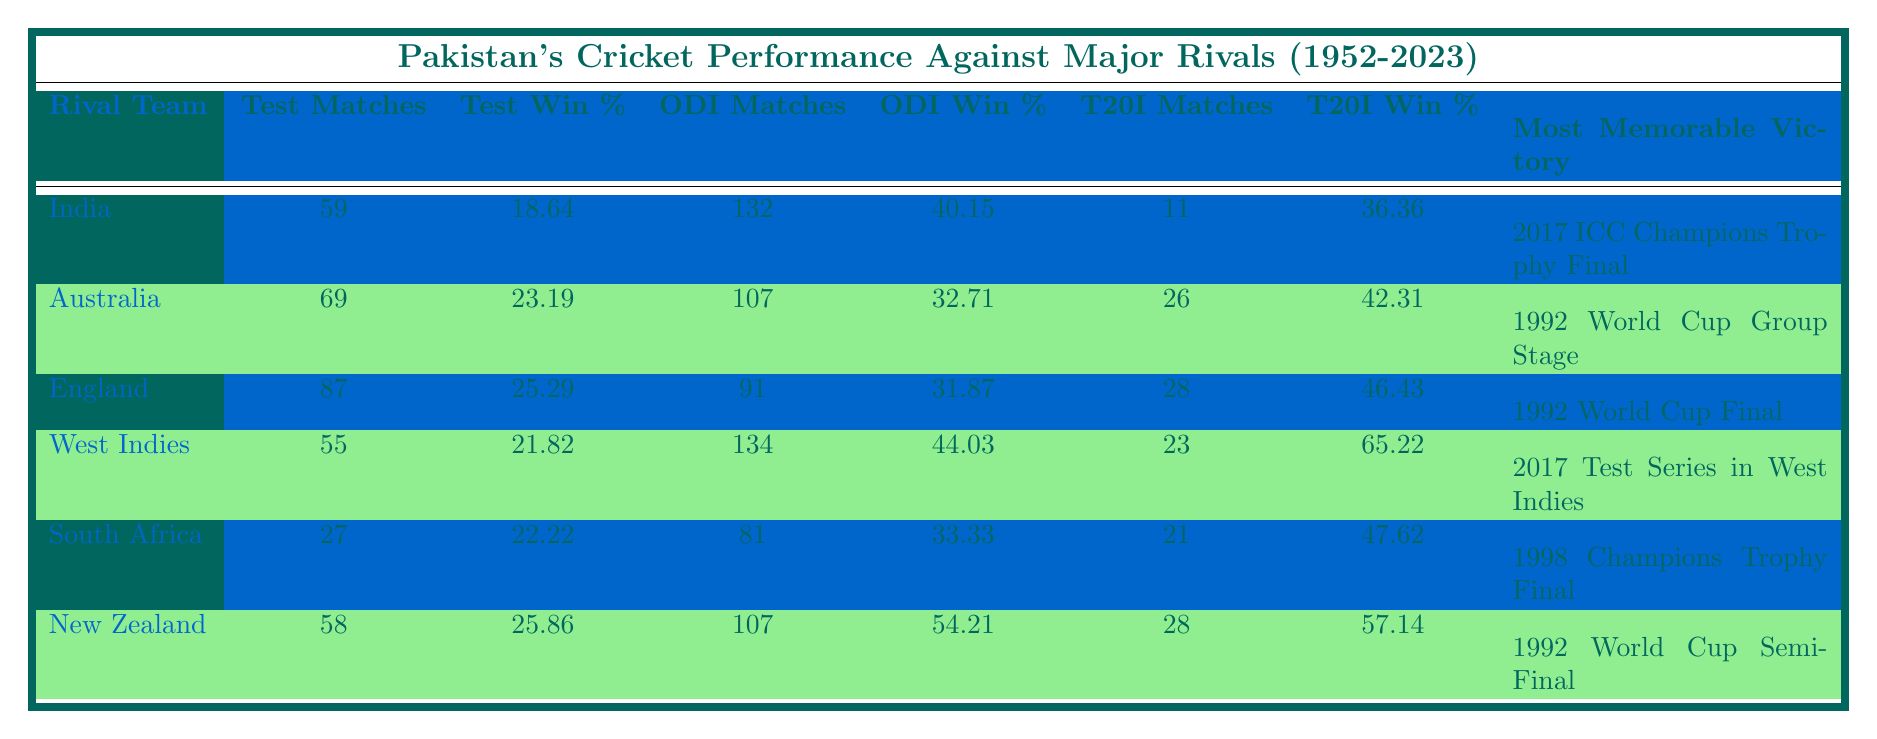What is Pakistan's win percentage against India in Test matches? The table shows that Pakistan has played 59 Test matches against India and has a win percentage of 18.64. Therefore, the win percentage against India is directly taken from the corresponding cell in the table.
Answer: 18.64 Which rivalry has the highest ODI win percentage for Pakistan? By comparing the ODI win percentages in the table, we see that Pakistan has a win percentage of 54.21 against New Zealand, which is the highest percentage among rival teams listed.
Answer: New Zealand True or False: Pakistan has more T20I matches against West Indies than Australia. The table indicates that Pakistan has played 23 T20I matches against West Indies and 26 T20I matches against Australia. Therefore, the statement is false as West Indies has fewer T20I matches than Australia.
Answer: False What is the average ODI win percentage against Australia and South Africa? First, we find the ODI win percentages for both teams: Australia has 32.71 and South Africa has 33.33. To find the average, we sum these percentages: (32.71 + 33.33) = 66.04 and then divide by 2, so the average is 66.04 / 2 = 33.02.
Answer: 33.02 What was Pakistan's most memorable victory against England? Referring to the table, the most memorable victory for Pakistan against England was in the 1992 World Cup Final. This information can be found in the "Most Memorable Victory" column under the English row.
Answer: 1992 World Cup Final 